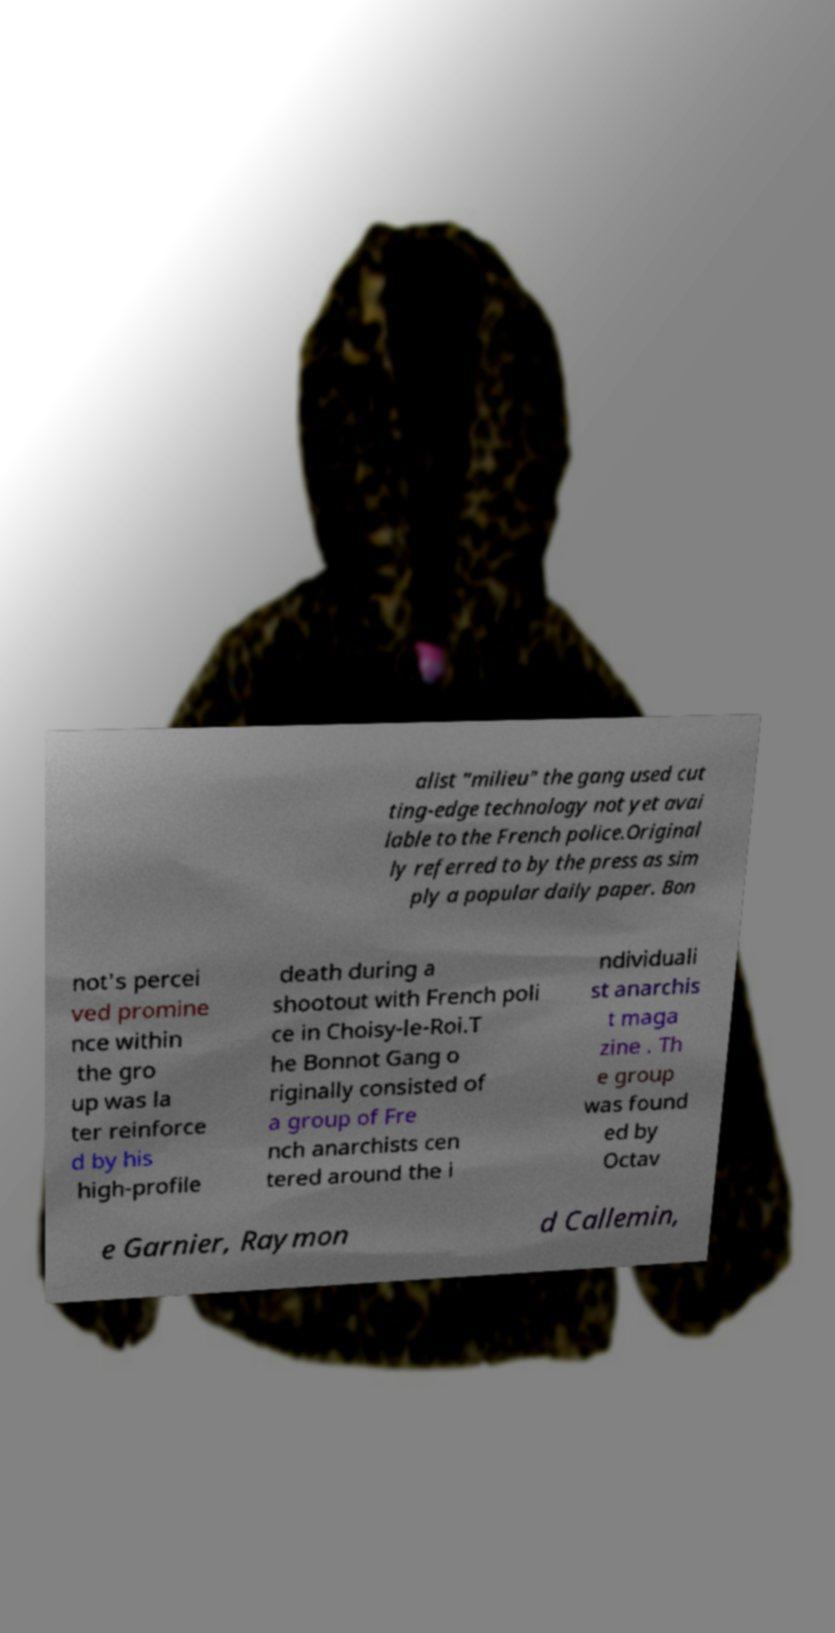What messages or text are displayed in this image? I need them in a readable, typed format. alist "milieu" the gang used cut ting-edge technology not yet avai lable to the French police.Original ly referred to by the press as sim ply a popular daily paper. Bon not's percei ved promine nce within the gro up was la ter reinforce d by his high-profile death during a shootout with French poli ce in Choisy-le-Roi.T he Bonnot Gang o riginally consisted of a group of Fre nch anarchists cen tered around the i ndividuali st anarchis t maga zine . Th e group was found ed by Octav e Garnier, Raymon d Callemin, 